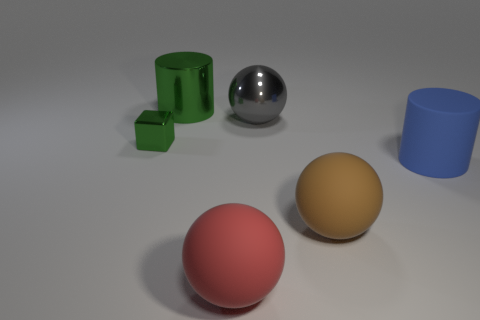Add 1 blue rubber things. How many objects exist? 7 Subtract all cylinders. How many objects are left? 4 Add 4 red balls. How many red balls are left? 5 Add 5 green metal objects. How many green metal objects exist? 7 Subtract 0 cyan balls. How many objects are left? 6 Subtract all small blocks. Subtract all brown balls. How many objects are left? 4 